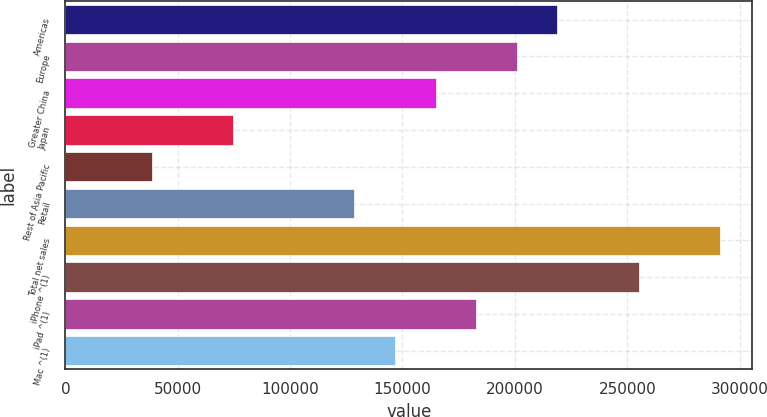<chart> <loc_0><loc_0><loc_500><loc_500><bar_chart><fcel>Americas<fcel>Europe<fcel>Greater China<fcel>Japan<fcel>Rest of Asia Pacific<fcel>Retail<fcel>Total net sales<fcel>iPhone ^(1)<fcel>iPad ^(1)<fcel>Mac ^(1)<nl><fcel>218897<fcel>200846<fcel>164744<fcel>74489.6<fcel>38387.8<fcel>128642<fcel>291100<fcel>254999<fcel>182795<fcel>146693<nl></chart> 